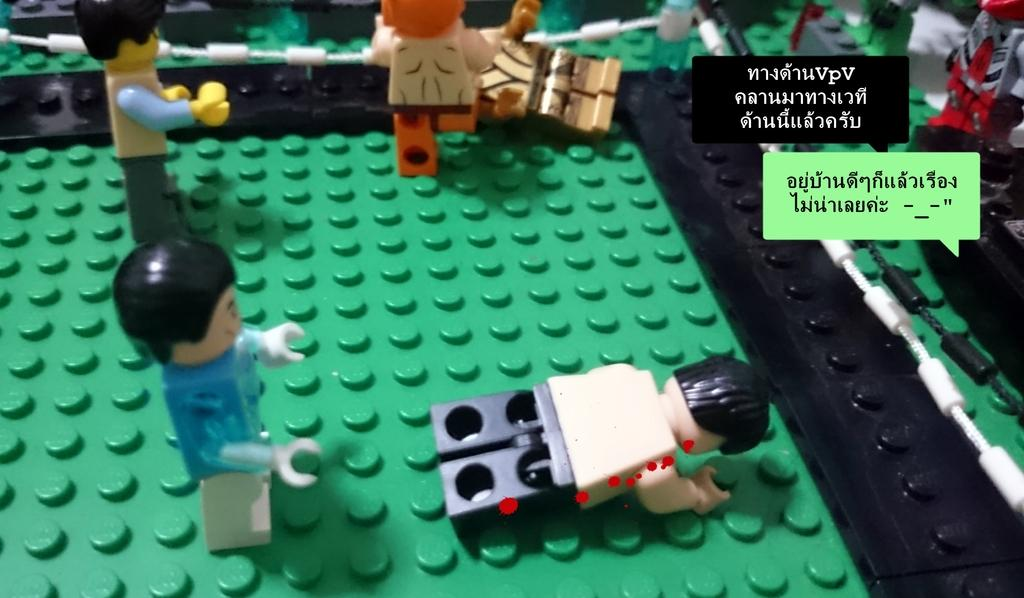What objects can be seen in the image? There are toys in the image. Where is the text located in the image? The text is on the right side of the image. What type of pear is being used as a spy in the image? There is no pear or any indication of spying in the image. 